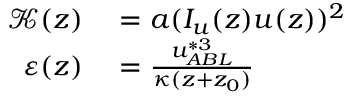Convert formula to latex. <formula><loc_0><loc_0><loc_500><loc_500>\begin{array} { r l } { \mathcal { K } ( z ) } & = a ( I _ { u } ( z ) u ( z ) ) ^ { 2 } } \\ { \varepsilon ( z ) } & = \frac { u _ { A B L } ^ { * 3 } } { \kappa ( z + z _ { 0 } ) } } \end{array}</formula> 